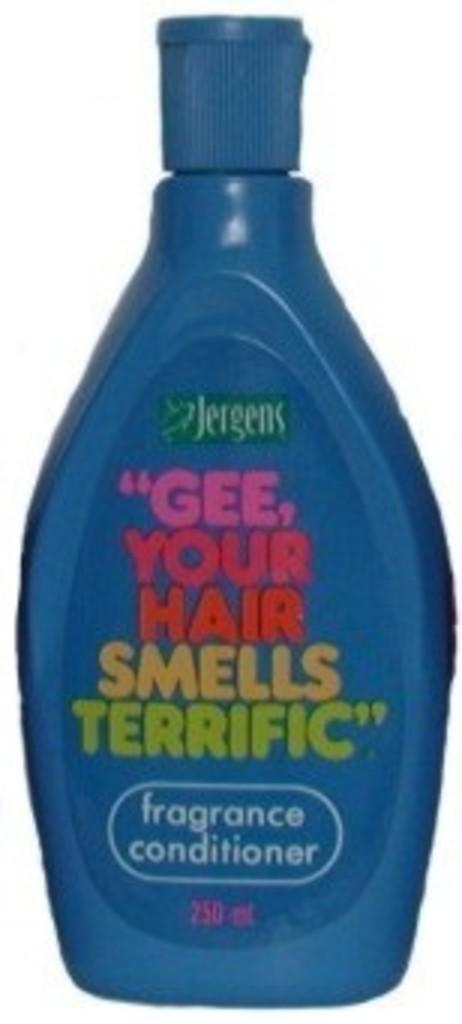How many ounces are in this conditioner?
Give a very brief answer. 250. 